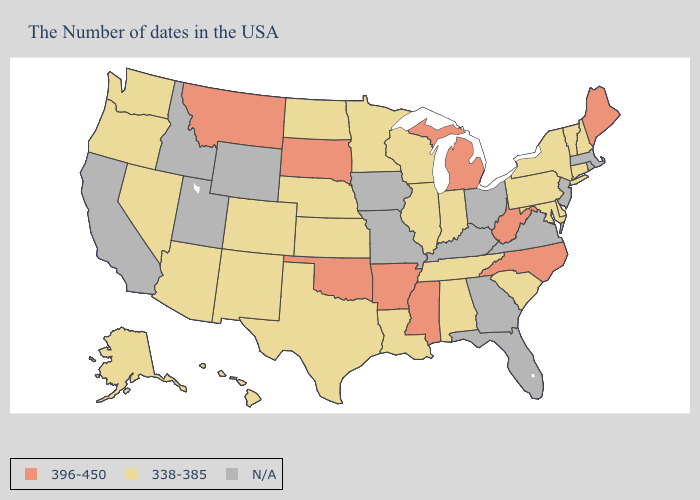What is the highest value in states that border Maine?
Short answer required. 338-385. What is the highest value in states that border Minnesota?
Be succinct. 396-450. What is the highest value in the USA?
Short answer required. 396-450. Which states hav the highest value in the MidWest?
Keep it brief. Michigan, South Dakota. What is the highest value in states that border Missouri?
Answer briefly. 396-450. What is the value of Maine?
Be succinct. 396-450. Among the states that border Pennsylvania , which have the lowest value?
Write a very short answer. New York, Delaware, Maryland. Among the states that border Idaho , does Nevada have the lowest value?
Write a very short answer. Yes. What is the value of Rhode Island?
Answer briefly. N/A. What is the value of Tennessee?
Keep it brief. 338-385. What is the highest value in the West ?
Be succinct. 396-450. Name the states that have a value in the range N/A?
Concise answer only. Massachusetts, Rhode Island, New Jersey, Virginia, Ohio, Florida, Georgia, Kentucky, Missouri, Iowa, Wyoming, Utah, Idaho, California. What is the value of Wisconsin?
Be succinct. 338-385. Does North Carolina have the lowest value in the USA?
Keep it brief. No. Does the first symbol in the legend represent the smallest category?
Answer briefly. No. 